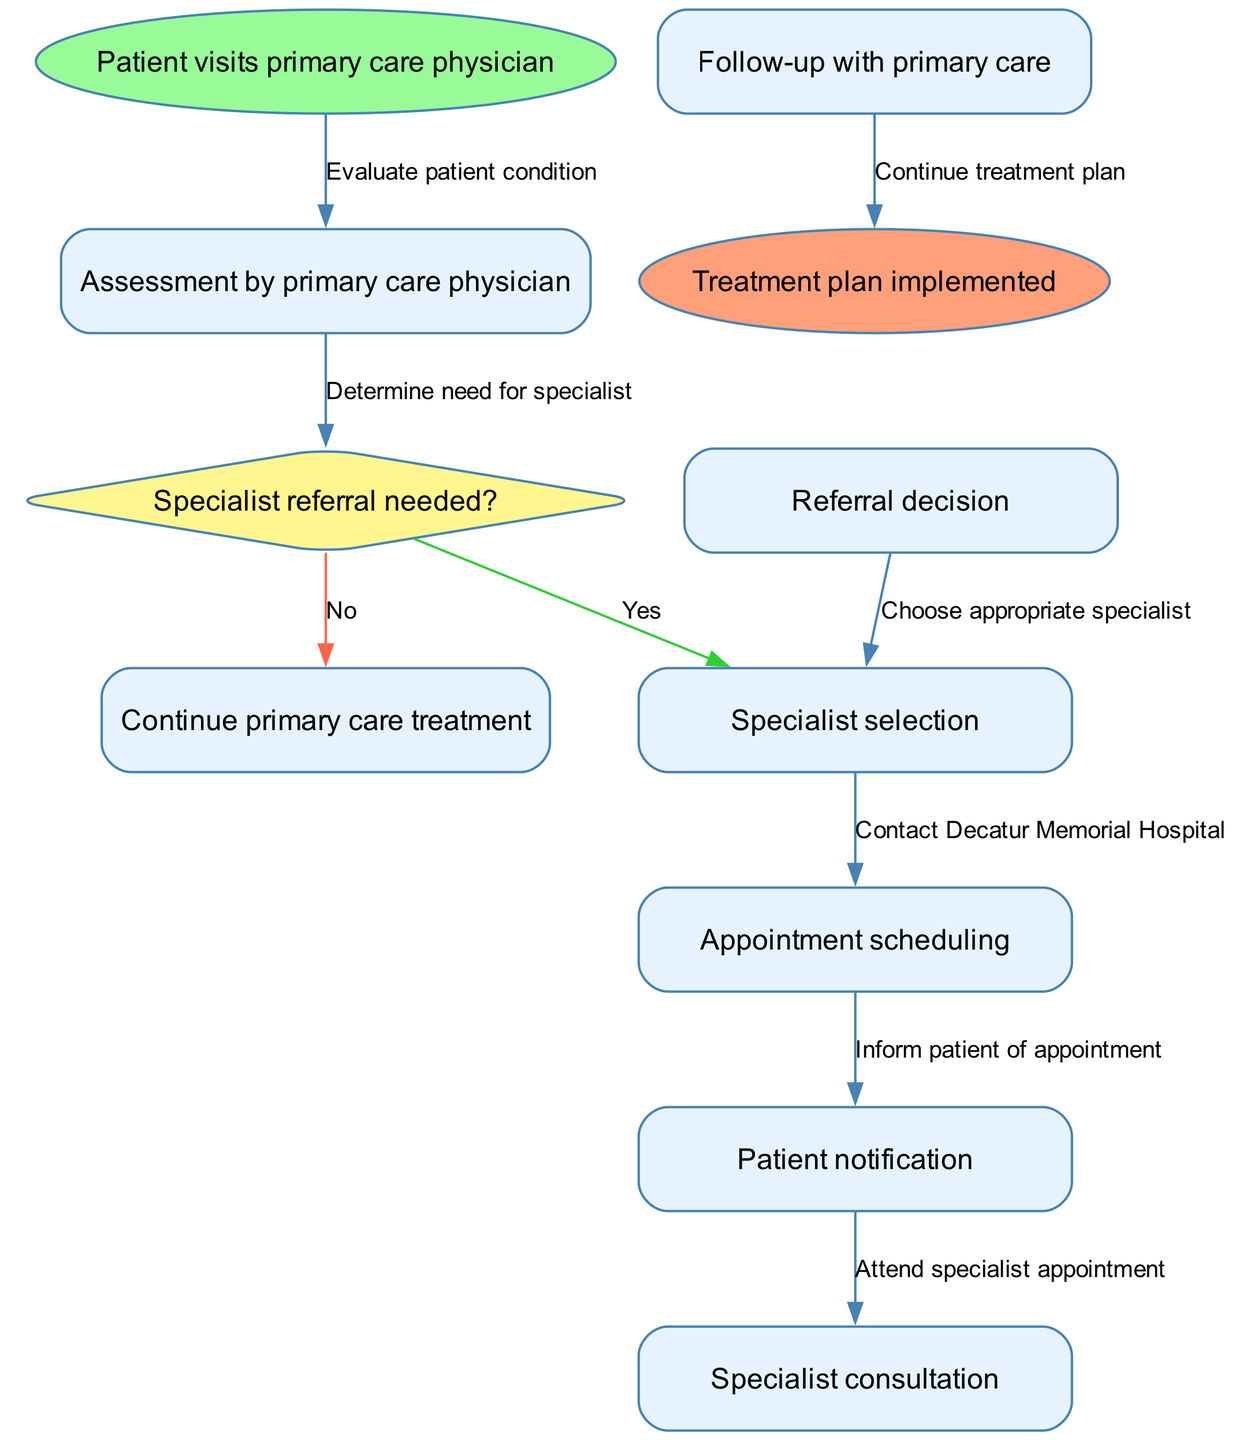What is the starting node of the patient referral process? The starting node is labeled "Patient visits primary care physician." It indicates the initial step in the flow chart.
Answer: Patient visits primary care physician How many nodes are there in the diagram? By counting the nodes listed in the diagram, including the start and end nodes, there are a total of 8 nodes.
Answer: 8 What decision is made after the assessment by the primary care physician? The decision made is whether a "Specialist referral" is needed or not, which leads to a specific pathway in the flow chart.
Answer: Specialist referral needed What is the last action taken in the patient referral process? The last action before reaching the end node is "Continue treatment plan," which signifies the conclusion of the process with an implemented plan.
Answer: Continue treatment plan Which node follows "Appointment scheduling"? After "Appointment scheduling," the next node is "Patient notification." This indicates that the patient is informed of the appointment details that were scheduled.
Answer: Patient notification If a specialist referral is not needed, what is the next step? If a specialist referral is not needed, the next step is to "Continue primary care treatment," indicating that the patient will remain under the care of their primary physician without needing specialist intervention.
Answer: Continue primary care treatment What color is the decision point node? The decision point node is colored in "yellow," specifically labeled with the question about the need for a specialist referral, which distinguishes it from the other steps.
Answer: yellow How does the flow proceed if a specialist referral is determined to be necessary? If a referral is needed, the flow proceeds to "Specialist selection," which leads to choosing an appropriate specialist for the patient's condition.
Answer: Specialist selection 